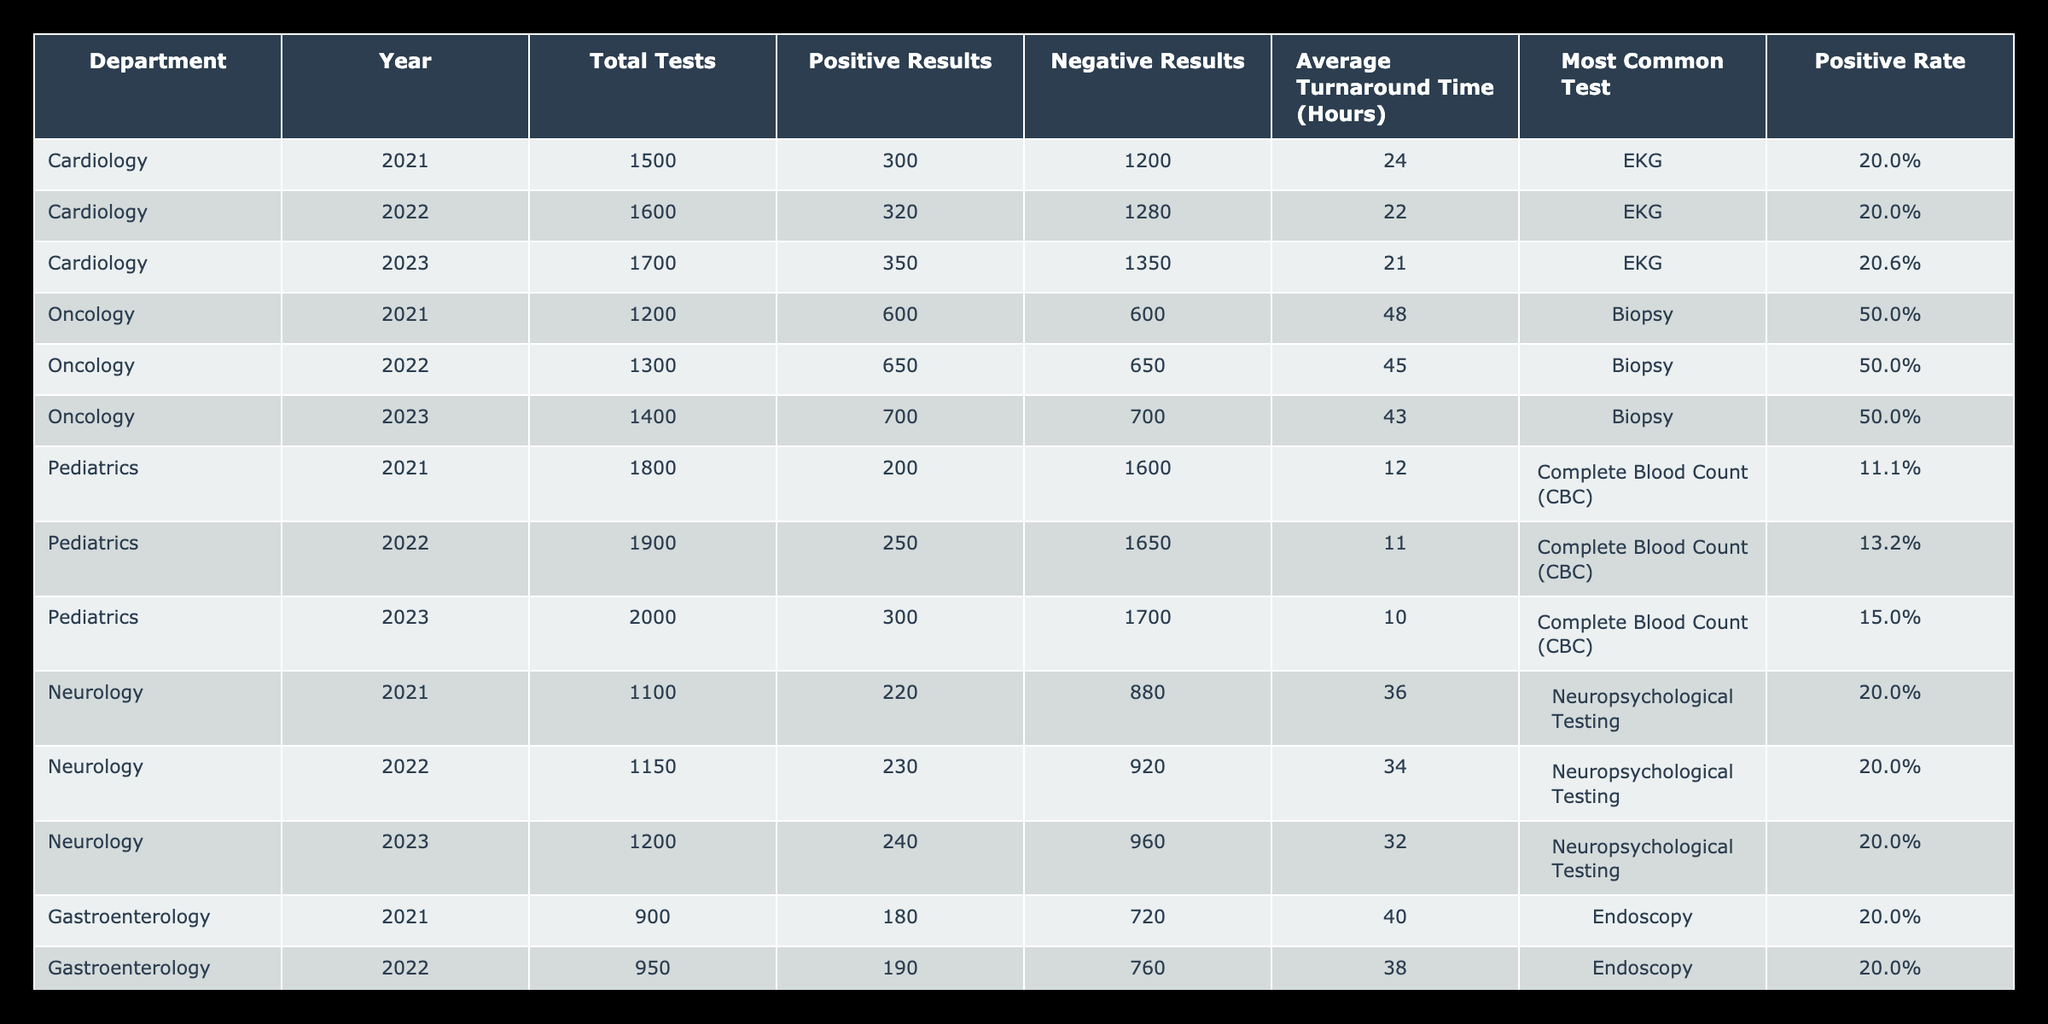What is the most common test conducted in the Cardiology department in 2023? According to the table, the most common test in the Cardiology department for the year 2023 is listed under the column "Most Common Test", which shows "EKG".
Answer: EKG In which year did the Pediatrics department have the highest number of total tests? By looking at the "Total Tests" column for the Pediatrics department, the values are 1800 in 2021, 1900 in 2022, and 2000 in 2023. The highest number is in 2023.
Answer: 2023 What is the positive rate for the Oncology department in 2022? To find the positive rate, divide the number of positive results (650) by the total tests (1300). The calculation is (650 / 1300) * 100 = 50%.
Answer: 50% Did the average turnaround time for lab tests decrease from 2021 to 2023 in the Neurology department? The average turnaround times for 2021, 2022, and 2023 are 36, 34, and 32 hours respectively. Since the values are decreasing over the years, the answer is yes.
Answer: Yes What is the total number of positive results across all departments in 2023? By adding the "Positive Results" for each department in 2023, we have 350 (Cardiology) + 700 (Oncology) + 300 (Pediatrics) + 240 (Neurology) + 200 (Gastroenterology) = 1790.
Answer: 1790 Which department had the highest average turnaround time in 2021? Reviewing the "Average Turnaround Time (Hours)" for 2021, the values are 24 for Cardiology, 48 for Oncology, 12 for Pediatrics, 36 for Neurology, and 40 for Gastroenterology. The highest is 48 hours for Oncology.
Answer: Oncology What was the increase in total tests from 2021 to 2023 for the Gastroenterology department? The total tests for Gastroenterology in 2021 is 900, and in 2023 it is 1000. The increase is calculated as 1000 - 900 = 100.
Answer: 100 Is the average turnaround time for lab tests in the Pediatrics department the lowest among all departments in 2023? In 2023, the average turnaround time for Pediatrics is 10 hours. Comparing this with the other departments in 2023: Cardiology (21), Oncology (43), Neurology (32), and Gastroenterology (36), Pediatrics does have the lowest time.
Answer: Yes 